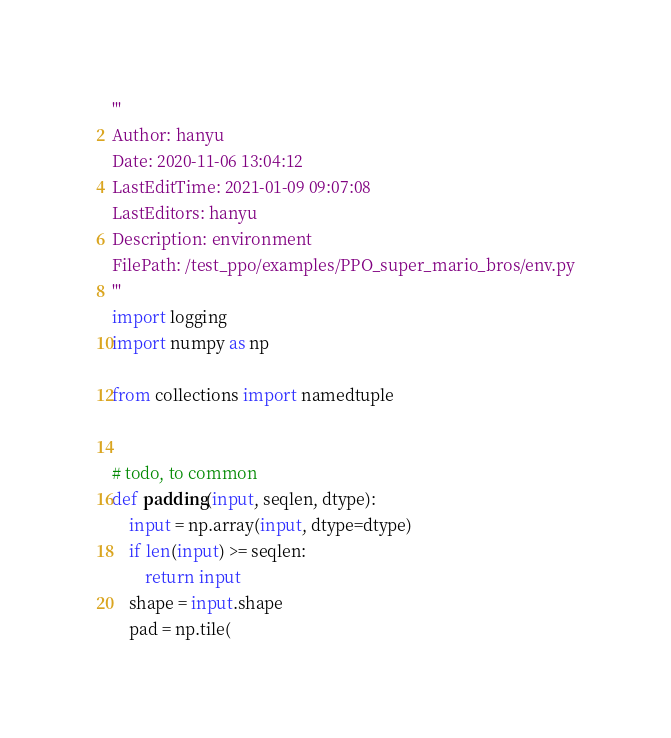<code> <loc_0><loc_0><loc_500><loc_500><_Python_>'''
Author: hanyu
Date: 2020-11-06 13:04:12
LastEditTime: 2021-01-09 09:07:08
LastEditors: hanyu
Description: environment
FilePath: /test_ppo/examples/PPO_super_mario_bros/env.py
'''
import logging
import numpy as np

from collections import namedtuple


# todo, to common
def padding(input, seqlen, dtype):
    input = np.array(input, dtype=dtype)
    if len(input) >= seqlen:
        return input
    shape = input.shape
    pad = np.tile(</code> 